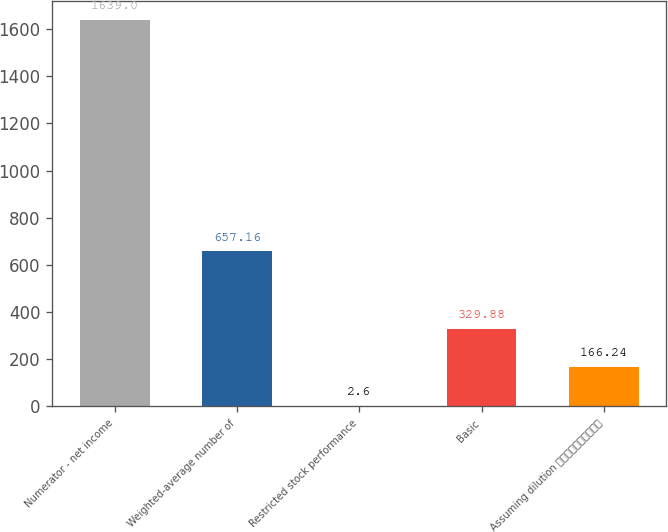<chart> <loc_0><loc_0><loc_500><loc_500><bar_chart><fcel>Numerator - net income<fcel>Weighted-average number of<fcel>Restricted stock performance<fcel>Basic<fcel>Assuming dilution ⎯⎯⎯⎯⎯⎯⎯⎯⎯⎯<nl><fcel>1639<fcel>657.16<fcel>2.6<fcel>329.88<fcel>166.24<nl></chart> 